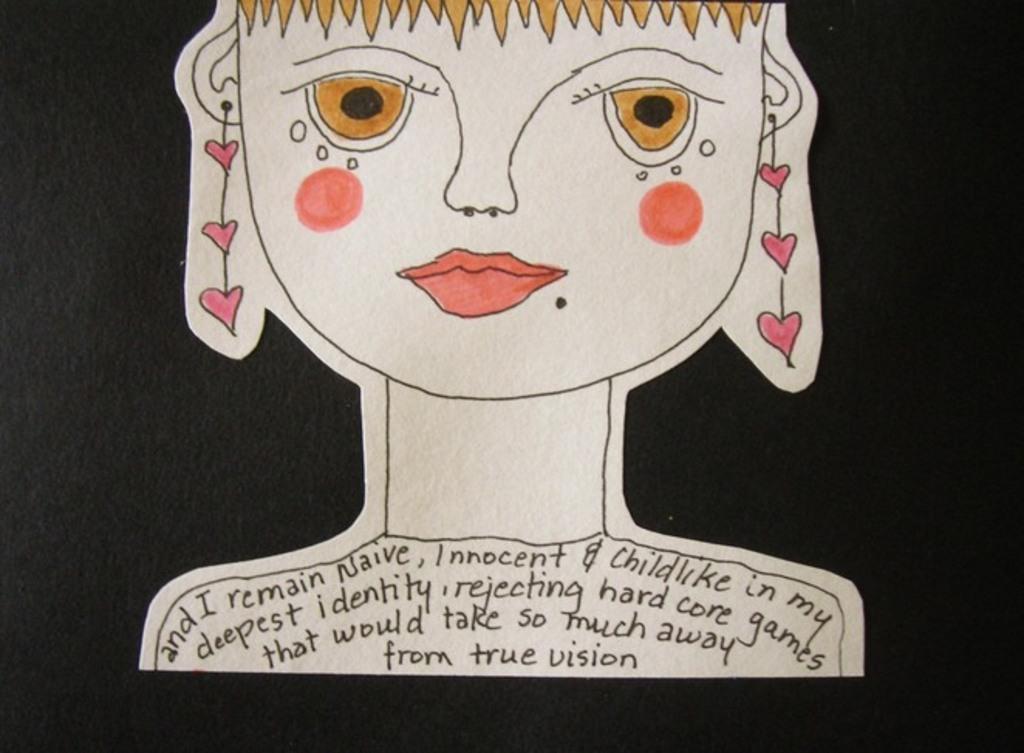Describe this image in one or two sentences. In this image there is dark background. We can see drawing of a girl. There is text on her shoulders. We can see lipstick and cheek shades. 